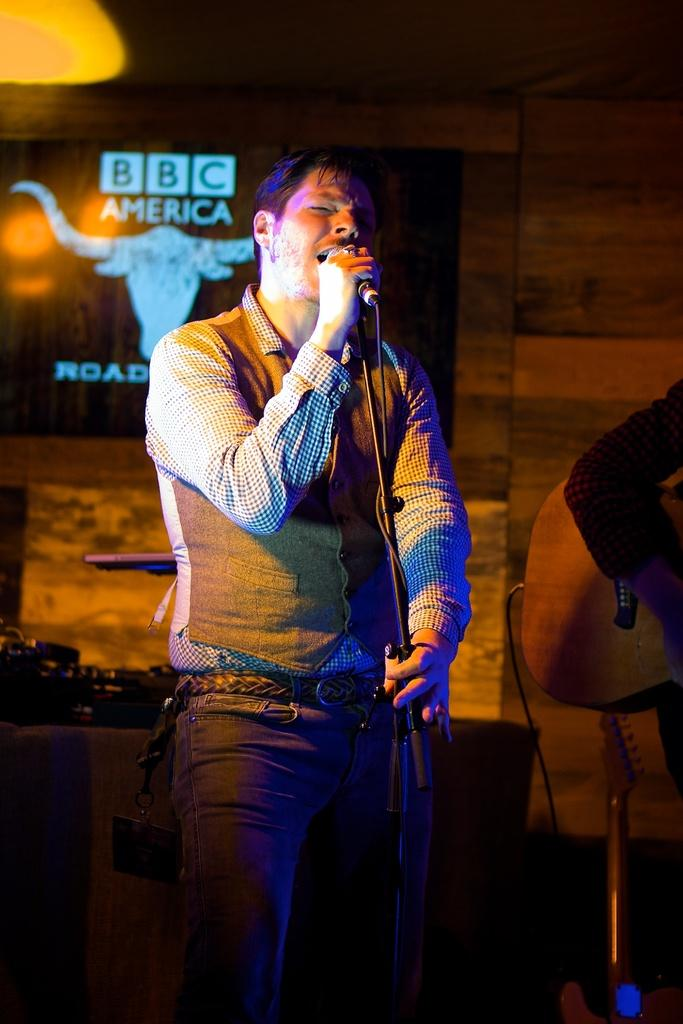What is the man in the image doing? The man is singing in the image. What is the man using while singing? The man is in front of a microphone. What can be seen in the background of the image? There is a wooden wall and a board in the background. How many houses are visible in the image? There are no houses visible in the image. What type of nest can be seen in the image? There is no nest present in the image. 